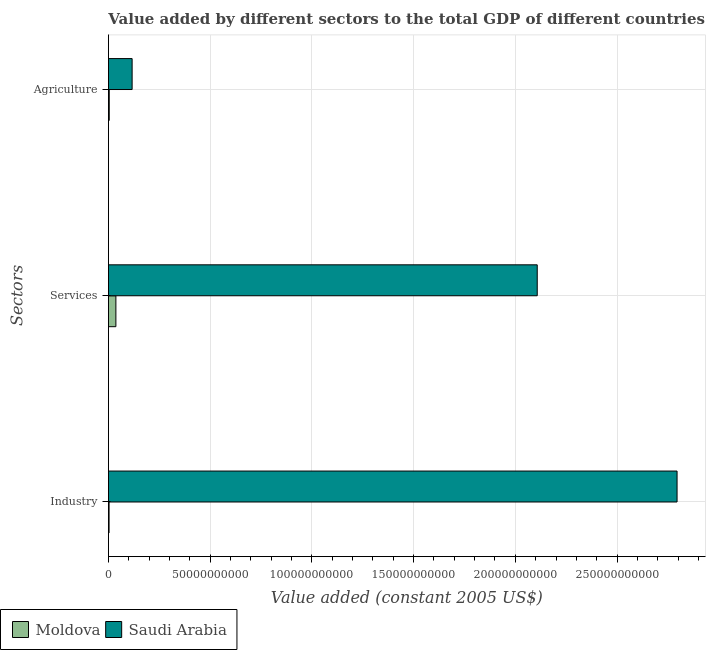How many groups of bars are there?
Your response must be concise. 3. What is the label of the 1st group of bars from the top?
Offer a terse response. Agriculture. What is the value added by services in Saudi Arabia?
Offer a terse response. 2.11e+11. Across all countries, what is the maximum value added by services?
Your answer should be very brief. 2.11e+11. Across all countries, what is the minimum value added by industrial sector?
Keep it short and to the point. 3.16e+08. In which country was the value added by agricultural sector maximum?
Give a very brief answer. Saudi Arabia. In which country was the value added by industrial sector minimum?
Keep it short and to the point. Moldova. What is the total value added by agricultural sector in the graph?
Give a very brief answer. 1.20e+1. What is the difference between the value added by agricultural sector in Moldova and that in Saudi Arabia?
Ensure brevity in your answer.  -1.12e+1. What is the difference between the value added by services in Saudi Arabia and the value added by industrial sector in Moldova?
Your answer should be very brief. 2.10e+11. What is the average value added by services per country?
Keep it short and to the point. 1.07e+11. What is the difference between the value added by industrial sector and value added by agricultural sector in Saudi Arabia?
Make the answer very short. 2.68e+11. What is the ratio of the value added by services in Moldova to that in Saudi Arabia?
Give a very brief answer. 0.02. Is the difference between the value added by services in Saudi Arabia and Moldova greater than the difference between the value added by agricultural sector in Saudi Arabia and Moldova?
Provide a succinct answer. Yes. What is the difference between the highest and the second highest value added by agricultural sector?
Offer a terse response. 1.12e+1. What is the difference between the highest and the lowest value added by industrial sector?
Your answer should be compact. 2.79e+11. In how many countries, is the value added by services greater than the average value added by services taken over all countries?
Provide a succinct answer. 1. What does the 1st bar from the top in Services represents?
Offer a terse response. Saudi Arabia. What does the 1st bar from the bottom in Industry represents?
Your answer should be compact. Moldova. How many bars are there?
Provide a succinct answer. 6. Are all the bars in the graph horizontal?
Provide a succinct answer. Yes. How many countries are there in the graph?
Provide a succinct answer. 2. Does the graph contain any zero values?
Make the answer very short. No. Does the graph contain grids?
Offer a terse response. Yes. How many legend labels are there?
Make the answer very short. 2. How are the legend labels stacked?
Give a very brief answer. Horizontal. What is the title of the graph?
Your answer should be compact. Value added by different sectors to the total GDP of different countries. What is the label or title of the X-axis?
Your answer should be very brief. Value added (constant 2005 US$). What is the label or title of the Y-axis?
Give a very brief answer. Sectors. What is the Value added (constant 2005 US$) in Moldova in Industry?
Your answer should be compact. 3.16e+08. What is the Value added (constant 2005 US$) of Saudi Arabia in Industry?
Ensure brevity in your answer.  2.79e+11. What is the Value added (constant 2005 US$) in Moldova in Services?
Provide a succinct answer. 3.67e+09. What is the Value added (constant 2005 US$) of Saudi Arabia in Services?
Your response must be concise. 2.11e+11. What is the Value added (constant 2005 US$) of Moldova in Agriculture?
Provide a succinct answer. 4.00e+08. What is the Value added (constant 2005 US$) of Saudi Arabia in Agriculture?
Ensure brevity in your answer.  1.16e+1. Across all Sectors, what is the maximum Value added (constant 2005 US$) in Moldova?
Make the answer very short. 3.67e+09. Across all Sectors, what is the maximum Value added (constant 2005 US$) in Saudi Arabia?
Your answer should be compact. 2.79e+11. Across all Sectors, what is the minimum Value added (constant 2005 US$) of Moldova?
Ensure brevity in your answer.  3.16e+08. Across all Sectors, what is the minimum Value added (constant 2005 US$) in Saudi Arabia?
Give a very brief answer. 1.16e+1. What is the total Value added (constant 2005 US$) of Moldova in the graph?
Give a very brief answer. 4.39e+09. What is the total Value added (constant 2005 US$) of Saudi Arabia in the graph?
Provide a succinct answer. 5.02e+11. What is the difference between the Value added (constant 2005 US$) in Moldova in Industry and that in Services?
Provide a short and direct response. -3.35e+09. What is the difference between the Value added (constant 2005 US$) of Saudi Arabia in Industry and that in Services?
Offer a very short reply. 6.87e+1. What is the difference between the Value added (constant 2005 US$) in Moldova in Industry and that in Agriculture?
Offer a very short reply. -8.40e+07. What is the difference between the Value added (constant 2005 US$) in Saudi Arabia in Industry and that in Agriculture?
Offer a terse response. 2.68e+11. What is the difference between the Value added (constant 2005 US$) in Moldova in Services and that in Agriculture?
Make the answer very short. 3.27e+09. What is the difference between the Value added (constant 2005 US$) of Saudi Arabia in Services and that in Agriculture?
Provide a succinct answer. 1.99e+11. What is the difference between the Value added (constant 2005 US$) of Moldova in Industry and the Value added (constant 2005 US$) of Saudi Arabia in Services?
Keep it short and to the point. -2.10e+11. What is the difference between the Value added (constant 2005 US$) in Moldova in Industry and the Value added (constant 2005 US$) in Saudi Arabia in Agriculture?
Provide a short and direct response. -1.13e+1. What is the difference between the Value added (constant 2005 US$) in Moldova in Services and the Value added (constant 2005 US$) in Saudi Arabia in Agriculture?
Provide a succinct answer. -7.97e+09. What is the average Value added (constant 2005 US$) of Moldova per Sectors?
Your answer should be very brief. 1.46e+09. What is the average Value added (constant 2005 US$) of Saudi Arabia per Sectors?
Your response must be concise. 1.67e+11. What is the difference between the Value added (constant 2005 US$) in Moldova and Value added (constant 2005 US$) in Saudi Arabia in Industry?
Provide a short and direct response. -2.79e+11. What is the difference between the Value added (constant 2005 US$) in Moldova and Value added (constant 2005 US$) in Saudi Arabia in Services?
Offer a terse response. -2.07e+11. What is the difference between the Value added (constant 2005 US$) of Moldova and Value added (constant 2005 US$) of Saudi Arabia in Agriculture?
Ensure brevity in your answer.  -1.12e+1. What is the ratio of the Value added (constant 2005 US$) of Moldova in Industry to that in Services?
Make the answer very short. 0.09. What is the ratio of the Value added (constant 2005 US$) of Saudi Arabia in Industry to that in Services?
Keep it short and to the point. 1.33. What is the ratio of the Value added (constant 2005 US$) of Moldova in Industry to that in Agriculture?
Offer a terse response. 0.79. What is the ratio of the Value added (constant 2005 US$) of Saudi Arabia in Industry to that in Agriculture?
Give a very brief answer. 24.01. What is the ratio of the Value added (constant 2005 US$) of Moldova in Services to that in Agriculture?
Make the answer very short. 9.18. What is the ratio of the Value added (constant 2005 US$) in Saudi Arabia in Services to that in Agriculture?
Provide a short and direct response. 18.1. What is the difference between the highest and the second highest Value added (constant 2005 US$) in Moldova?
Keep it short and to the point. 3.27e+09. What is the difference between the highest and the second highest Value added (constant 2005 US$) in Saudi Arabia?
Make the answer very short. 6.87e+1. What is the difference between the highest and the lowest Value added (constant 2005 US$) of Moldova?
Offer a very short reply. 3.35e+09. What is the difference between the highest and the lowest Value added (constant 2005 US$) in Saudi Arabia?
Offer a very short reply. 2.68e+11. 